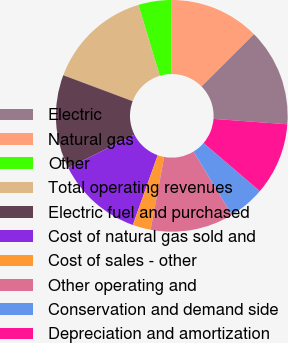Convert chart to OTSL. <chart><loc_0><loc_0><loc_500><loc_500><pie_chart><fcel>Electric<fcel>Natural gas<fcel>Other<fcel>Total operating revenues<fcel>Electric fuel and purchased<fcel>Cost of natural gas sold and<fcel>Cost of sales - other<fcel>Other operating and<fcel>Conservation and demand side<fcel>Depreciation and amortization<nl><fcel>13.64%<fcel>12.63%<fcel>4.55%<fcel>14.65%<fcel>13.13%<fcel>12.12%<fcel>2.53%<fcel>11.62%<fcel>5.05%<fcel>10.1%<nl></chart> 